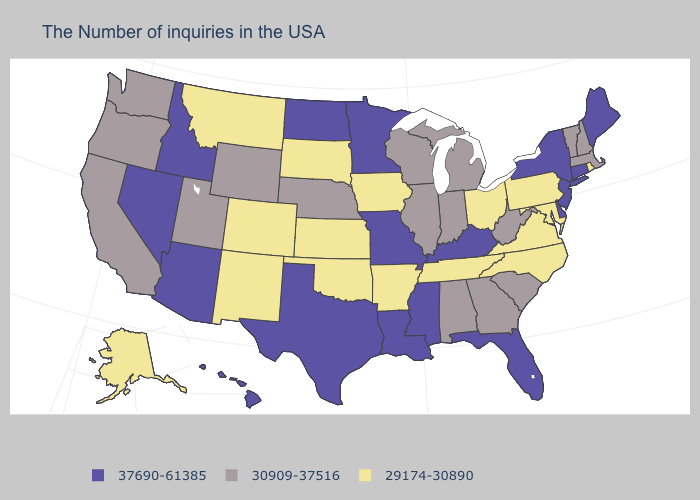What is the value of Connecticut?
Quick response, please. 37690-61385. Which states have the lowest value in the USA?
Write a very short answer. Rhode Island, Maryland, Pennsylvania, Virginia, North Carolina, Ohio, Tennessee, Arkansas, Iowa, Kansas, Oklahoma, South Dakota, Colorado, New Mexico, Montana, Alaska. Does the map have missing data?
Answer briefly. No. Which states have the lowest value in the USA?
Be succinct. Rhode Island, Maryland, Pennsylvania, Virginia, North Carolina, Ohio, Tennessee, Arkansas, Iowa, Kansas, Oklahoma, South Dakota, Colorado, New Mexico, Montana, Alaska. Does Washington have the highest value in the West?
Give a very brief answer. No. Does New York have the highest value in the USA?
Write a very short answer. Yes. What is the value of Rhode Island?
Write a very short answer. 29174-30890. How many symbols are there in the legend?
Write a very short answer. 3. Does Oklahoma have a lower value than Idaho?
Be succinct. Yes. What is the value of Ohio?
Give a very brief answer. 29174-30890. Which states have the highest value in the USA?
Be succinct. Maine, Connecticut, New York, New Jersey, Delaware, Florida, Kentucky, Mississippi, Louisiana, Missouri, Minnesota, Texas, North Dakota, Arizona, Idaho, Nevada, Hawaii. Among the states that border Texas , which have the highest value?
Keep it brief. Louisiana. Among the states that border Louisiana , which have the highest value?
Short answer required. Mississippi, Texas. What is the lowest value in the Northeast?
Be succinct. 29174-30890. How many symbols are there in the legend?
Write a very short answer. 3. 